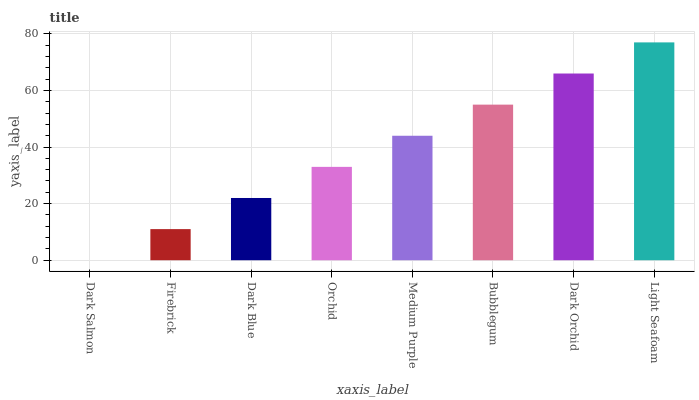Is Firebrick the minimum?
Answer yes or no. No. Is Firebrick the maximum?
Answer yes or no. No. Is Firebrick greater than Dark Salmon?
Answer yes or no. Yes. Is Dark Salmon less than Firebrick?
Answer yes or no. Yes. Is Dark Salmon greater than Firebrick?
Answer yes or no. No. Is Firebrick less than Dark Salmon?
Answer yes or no. No. Is Medium Purple the high median?
Answer yes or no. Yes. Is Orchid the low median?
Answer yes or no. Yes. Is Bubblegum the high median?
Answer yes or no. No. Is Bubblegum the low median?
Answer yes or no. No. 